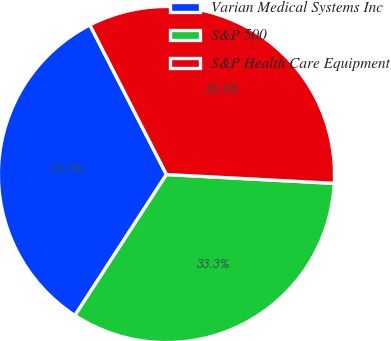Convert chart. <chart><loc_0><loc_0><loc_500><loc_500><pie_chart><fcel>Varian Medical Systems Inc<fcel>S&P 500<fcel>S&P Health Care Equipment<nl><fcel>33.3%<fcel>33.33%<fcel>33.37%<nl></chart> 